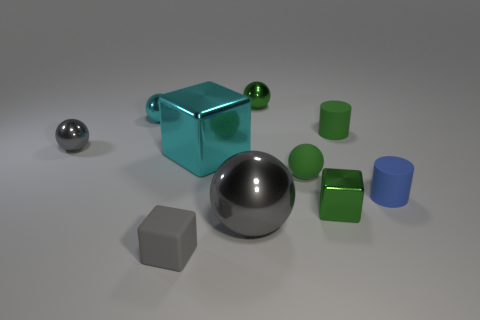Is the number of small green shiny things that are to the right of the small blue cylinder greater than the number of cyan cubes that are in front of the large cyan metallic block?
Make the answer very short. No. What size is the matte ball?
Offer a very short reply. Small. There is a matte thing in front of the green block; is its color the same as the matte sphere?
Your answer should be very brief. No. Are there any other things that are the same shape as the blue object?
Offer a terse response. Yes. There is a tiny thing that is behind the small cyan thing; are there any small metal objects behind it?
Provide a succinct answer. No. Is the number of small green cylinders that are left of the big cyan shiny thing less than the number of blue cylinders that are to the left of the green metal block?
Offer a terse response. No. How big is the block that is to the left of the big thing behind the metal object in front of the tiny green shiny block?
Give a very brief answer. Small. Does the cyan metal thing that is to the right of the matte block have the same size as the small gray rubber thing?
Your response must be concise. No. How many other objects are there of the same material as the small gray cube?
Your answer should be very brief. 3. Are there more tiny cylinders than cyan balls?
Provide a succinct answer. Yes. 